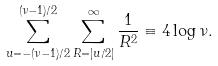Convert formula to latex. <formula><loc_0><loc_0><loc_500><loc_500>\sum _ { u = - ( \nu - 1 ) / 2 } ^ { ( \nu - 1 ) / 2 } \sum _ { R = | u / 2 | } ^ { \infty } \frac { 1 } { R ^ { 2 } } \equiv 4 \log \nu .</formula> 